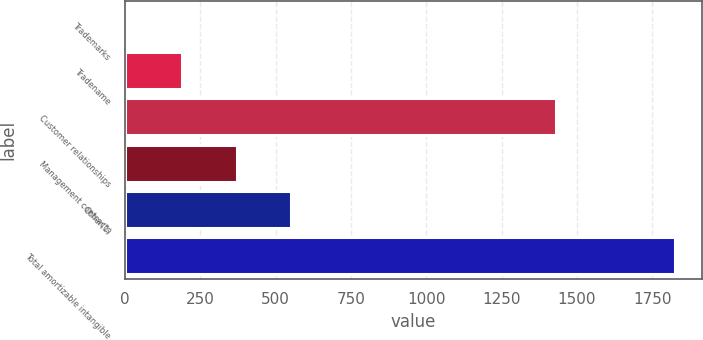<chart> <loc_0><loc_0><loc_500><loc_500><bar_chart><fcel>Trademarks<fcel>Tradename<fcel>Customer relationships<fcel>Management contracts<fcel>Other(1)<fcel>Total amortizable intangible<nl><fcel>6<fcel>187.8<fcel>1430<fcel>369.6<fcel>551.4<fcel>1824<nl></chart> 